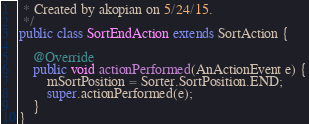Convert code to text. <code><loc_0><loc_0><loc_500><loc_500><_Java_> * Created by akopian on 5/24/15.
 */
public class SortEndAction extends SortAction {

    @Override
    public void actionPerformed(AnActionEvent e) {
        mSortPosition = Sorter.SortPosition.END;
        super.actionPerformed(e);
    }
}
</code> 